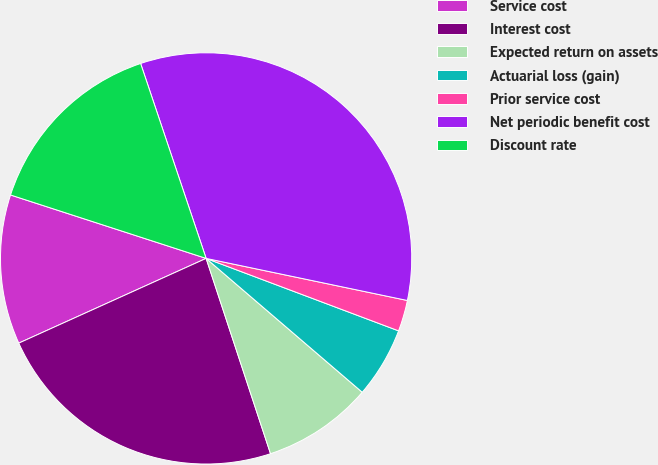<chart> <loc_0><loc_0><loc_500><loc_500><pie_chart><fcel>Service cost<fcel>Interest cost<fcel>Expected return on assets<fcel>Actuarial loss (gain)<fcel>Prior service cost<fcel>Net periodic benefit cost<fcel>Discount rate<nl><fcel>11.75%<fcel>23.31%<fcel>8.65%<fcel>5.55%<fcel>2.45%<fcel>33.44%<fcel>14.85%<nl></chart> 